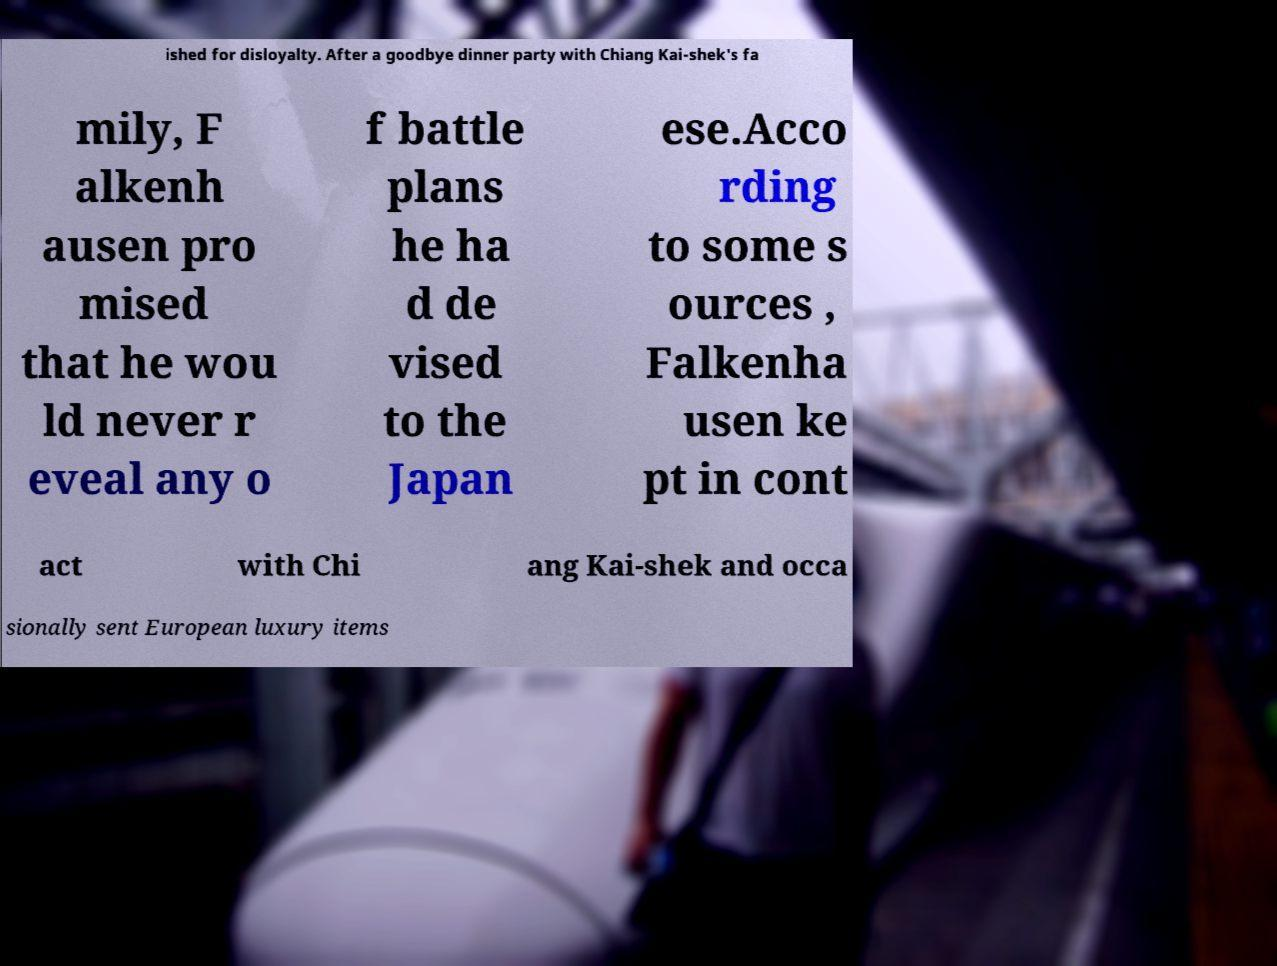I need the written content from this picture converted into text. Can you do that? ished for disloyalty. After a goodbye dinner party with Chiang Kai-shek's fa mily, F alkenh ausen pro mised that he wou ld never r eveal any o f battle plans he ha d de vised to the Japan ese.Acco rding to some s ources , Falkenha usen ke pt in cont act with Chi ang Kai-shek and occa sionally sent European luxury items 